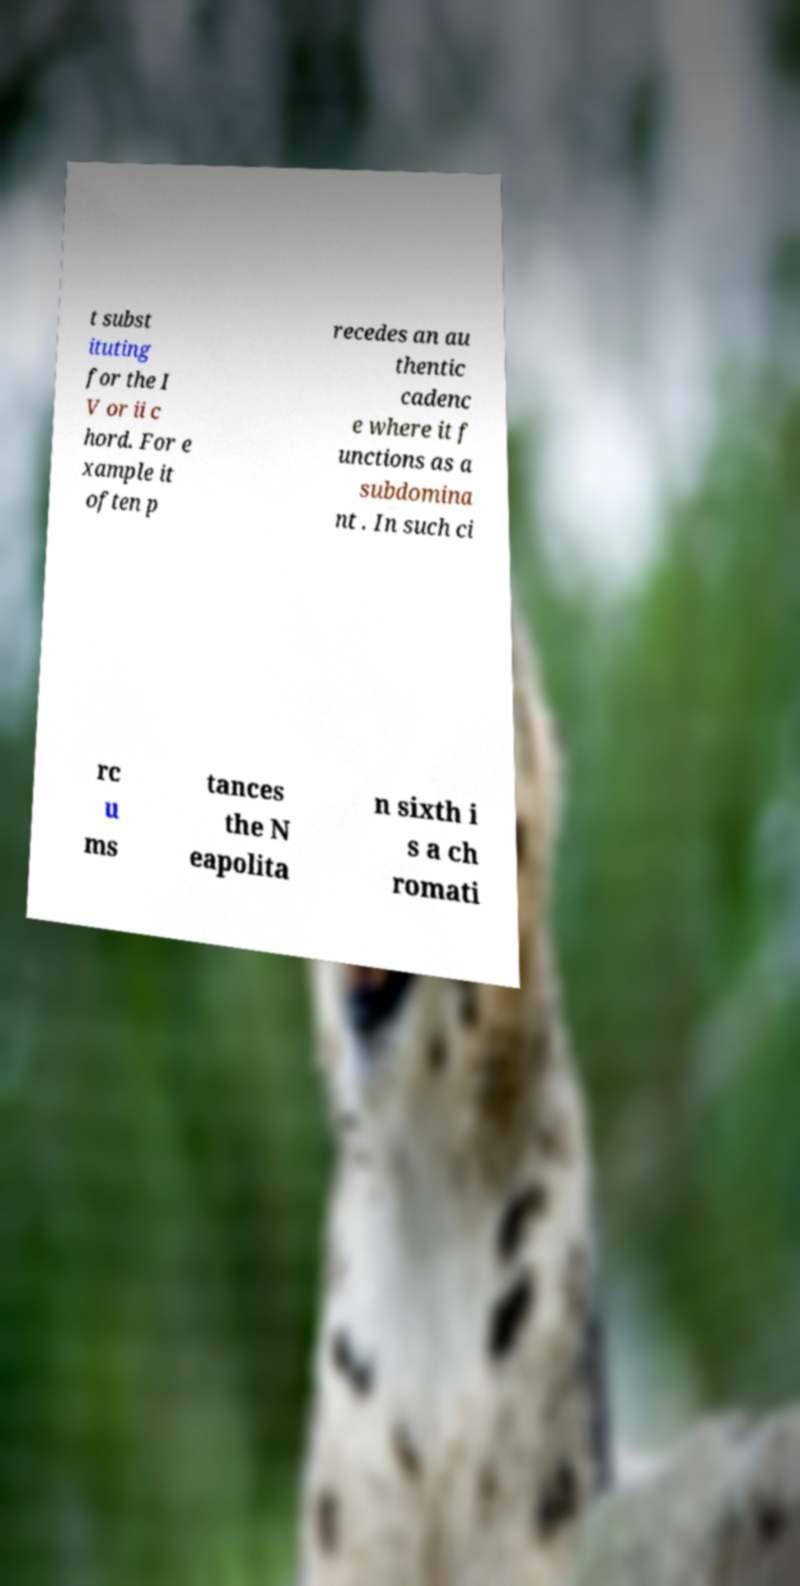Could you assist in decoding the text presented in this image and type it out clearly? t subst ituting for the I V or ii c hord. For e xample it often p recedes an au thentic cadenc e where it f unctions as a subdomina nt . In such ci rc u ms tances the N eapolita n sixth i s a ch romati 